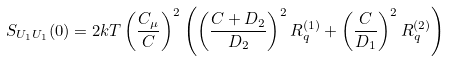<formula> <loc_0><loc_0><loc_500><loc_500>S _ { U _ { 1 } U _ { 1 } } ( 0 ) = 2 k T \left ( \frac { C _ { \mu } } { C } \right ) ^ { 2 } \left ( \left ( \frac { C + D _ { 2 } } { D _ { 2 } } \right ) ^ { 2 } R ^ { ( 1 ) } _ { q } + \left ( \frac { C } { D _ { 1 } } \right ) ^ { 2 } R ^ { ( 2 ) } _ { q } \right )</formula> 